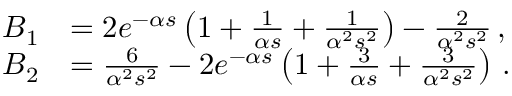<formula> <loc_0><loc_0><loc_500><loc_500>\begin{array} { r l } { B _ { 1 } } & { = 2 e ^ { - \alpha s } \left ( 1 + \frac { 1 } { \alpha s } + \frac { 1 } { \alpha ^ { 2 } s ^ { 2 } } \right ) - \frac { 2 } { \alpha ^ { 2 } s ^ { 2 } } \, , } \\ { B _ { 2 } } & { = \frac { 6 } { \alpha ^ { 2 } s ^ { 2 } } - 2 e ^ { - \alpha s } \left ( 1 + \frac { 3 } { \alpha s } + \frac { 3 } { \alpha ^ { 2 } s ^ { 2 } } \right ) \, . } \end{array}</formula> 